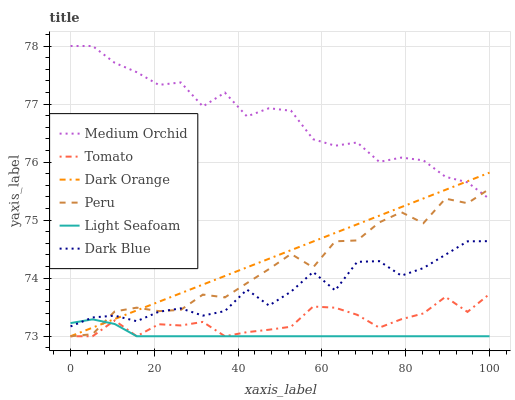Does Light Seafoam have the minimum area under the curve?
Answer yes or no. Yes. Does Medium Orchid have the maximum area under the curve?
Answer yes or no. Yes. Does Dark Orange have the minimum area under the curve?
Answer yes or no. No. Does Dark Orange have the maximum area under the curve?
Answer yes or no. No. Is Dark Orange the smoothest?
Answer yes or no. Yes. Is Medium Orchid the roughest?
Answer yes or no. Yes. Is Medium Orchid the smoothest?
Answer yes or no. No. Is Dark Orange the roughest?
Answer yes or no. No. Does Medium Orchid have the lowest value?
Answer yes or no. No. Does Medium Orchid have the highest value?
Answer yes or no. Yes. Does Dark Orange have the highest value?
Answer yes or no. No. Is Light Seafoam less than Medium Orchid?
Answer yes or no. Yes. Is Medium Orchid greater than Light Seafoam?
Answer yes or no. Yes. Does Tomato intersect Peru?
Answer yes or no. Yes. Is Tomato less than Peru?
Answer yes or no. No. Is Tomato greater than Peru?
Answer yes or no. No. Does Light Seafoam intersect Medium Orchid?
Answer yes or no. No. 